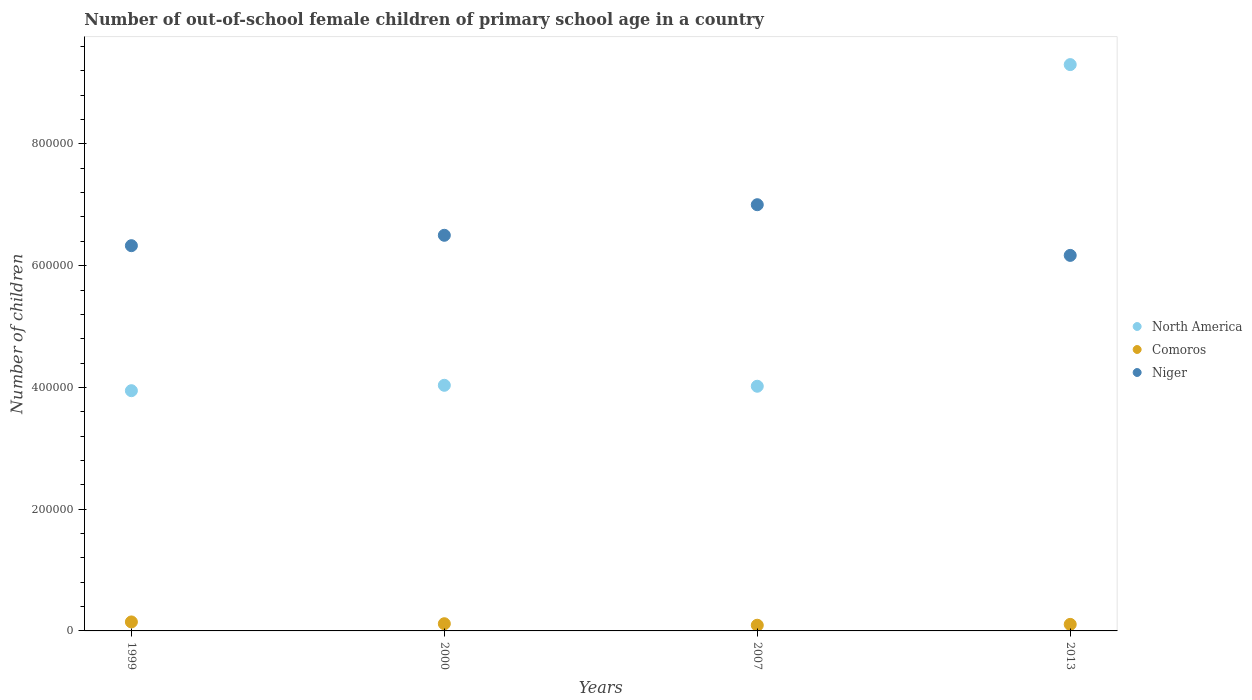Is the number of dotlines equal to the number of legend labels?
Offer a very short reply. Yes. What is the number of out-of-school female children in North America in 2007?
Make the answer very short. 4.02e+05. Across all years, what is the maximum number of out-of-school female children in Niger?
Provide a succinct answer. 7.00e+05. Across all years, what is the minimum number of out-of-school female children in Comoros?
Your answer should be very brief. 9336. In which year was the number of out-of-school female children in North America maximum?
Your answer should be compact. 2013. In which year was the number of out-of-school female children in Comoros minimum?
Give a very brief answer. 2007. What is the total number of out-of-school female children in Niger in the graph?
Your answer should be compact. 2.60e+06. What is the difference between the number of out-of-school female children in North America in 1999 and that in 2000?
Your response must be concise. -8858. What is the difference between the number of out-of-school female children in North America in 2000 and the number of out-of-school female children in Comoros in 2007?
Ensure brevity in your answer.  3.94e+05. What is the average number of out-of-school female children in North America per year?
Ensure brevity in your answer.  5.33e+05. In the year 2007, what is the difference between the number of out-of-school female children in Niger and number of out-of-school female children in Comoros?
Your response must be concise. 6.91e+05. What is the ratio of the number of out-of-school female children in Comoros in 1999 to that in 2013?
Give a very brief answer. 1.37. Is the difference between the number of out-of-school female children in Niger in 2000 and 2013 greater than the difference between the number of out-of-school female children in Comoros in 2000 and 2013?
Your answer should be compact. Yes. What is the difference between the highest and the second highest number of out-of-school female children in North America?
Offer a very short reply. 5.27e+05. What is the difference between the highest and the lowest number of out-of-school female children in Niger?
Ensure brevity in your answer.  8.32e+04. Is the sum of the number of out-of-school female children in Niger in 1999 and 2000 greater than the maximum number of out-of-school female children in North America across all years?
Offer a very short reply. Yes. Is the number of out-of-school female children in North America strictly greater than the number of out-of-school female children in Niger over the years?
Keep it short and to the point. No. How many dotlines are there?
Your response must be concise. 3. How many years are there in the graph?
Offer a very short reply. 4. Does the graph contain grids?
Offer a terse response. No. What is the title of the graph?
Give a very brief answer. Number of out-of-school female children of primary school age in a country. Does "Zambia" appear as one of the legend labels in the graph?
Provide a succinct answer. No. What is the label or title of the Y-axis?
Offer a very short reply. Number of children. What is the Number of children in North America in 1999?
Ensure brevity in your answer.  3.95e+05. What is the Number of children of Comoros in 1999?
Your response must be concise. 1.48e+04. What is the Number of children in Niger in 1999?
Give a very brief answer. 6.33e+05. What is the Number of children of North America in 2000?
Give a very brief answer. 4.03e+05. What is the Number of children in Comoros in 2000?
Provide a succinct answer. 1.18e+04. What is the Number of children in Niger in 2000?
Keep it short and to the point. 6.50e+05. What is the Number of children of North America in 2007?
Ensure brevity in your answer.  4.02e+05. What is the Number of children in Comoros in 2007?
Give a very brief answer. 9336. What is the Number of children in Niger in 2007?
Ensure brevity in your answer.  7.00e+05. What is the Number of children in North America in 2013?
Your answer should be very brief. 9.30e+05. What is the Number of children in Comoros in 2013?
Provide a succinct answer. 1.07e+04. What is the Number of children in Niger in 2013?
Your answer should be compact. 6.17e+05. Across all years, what is the maximum Number of children of North America?
Keep it short and to the point. 9.30e+05. Across all years, what is the maximum Number of children of Comoros?
Your response must be concise. 1.48e+04. Across all years, what is the maximum Number of children of Niger?
Ensure brevity in your answer.  7.00e+05. Across all years, what is the minimum Number of children of North America?
Offer a terse response. 3.95e+05. Across all years, what is the minimum Number of children of Comoros?
Your answer should be compact. 9336. Across all years, what is the minimum Number of children of Niger?
Make the answer very short. 6.17e+05. What is the total Number of children in North America in the graph?
Give a very brief answer. 2.13e+06. What is the total Number of children of Comoros in the graph?
Keep it short and to the point. 4.67e+04. What is the total Number of children of Niger in the graph?
Offer a very short reply. 2.60e+06. What is the difference between the Number of children in North America in 1999 and that in 2000?
Your response must be concise. -8858. What is the difference between the Number of children of Comoros in 1999 and that in 2000?
Provide a succinct answer. 2941. What is the difference between the Number of children of Niger in 1999 and that in 2000?
Keep it short and to the point. -1.71e+04. What is the difference between the Number of children of North America in 1999 and that in 2007?
Ensure brevity in your answer.  -7308. What is the difference between the Number of children in Comoros in 1999 and that in 2007?
Offer a very short reply. 5426. What is the difference between the Number of children of Niger in 1999 and that in 2007?
Your answer should be very brief. -6.73e+04. What is the difference between the Number of children of North America in 1999 and that in 2013?
Offer a very short reply. -5.36e+05. What is the difference between the Number of children in Comoros in 1999 and that in 2013?
Make the answer very short. 4013. What is the difference between the Number of children of Niger in 1999 and that in 2013?
Your answer should be compact. 1.59e+04. What is the difference between the Number of children in North America in 2000 and that in 2007?
Provide a short and direct response. 1550. What is the difference between the Number of children in Comoros in 2000 and that in 2007?
Provide a succinct answer. 2485. What is the difference between the Number of children in Niger in 2000 and that in 2007?
Your answer should be very brief. -5.02e+04. What is the difference between the Number of children of North America in 2000 and that in 2013?
Offer a very short reply. -5.27e+05. What is the difference between the Number of children of Comoros in 2000 and that in 2013?
Your response must be concise. 1072. What is the difference between the Number of children in Niger in 2000 and that in 2013?
Your response must be concise. 3.30e+04. What is the difference between the Number of children in North America in 2007 and that in 2013?
Your response must be concise. -5.28e+05. What is the difference between the Number of children of Comoros in 2007 and that in 2013?
Give a very brief answer. -1413. What is the difference between the Number of children of Niger in 2007 and that in 2013?
Offer a terse response. 8.32e+04. What is the difference between the Number of children in North America in 1999 and the Number of children in Comoros in 2000?
Ensure brevity in your answer.  3.83e+05. What is the difference between the Number of children of North America in 1999 and the Number of children of Niger in 2000?
Keep it short and to the point. -2.55e+05. What is the difference between the Number of children of Comoros in 1999 and the Number of children of Niger in 2000?
Your answer should be very brief. -6.35e+05. What is the difference between the Number of children of North America in 1999 and the Number of children of Comoros in 2007?
Ensure brevity in your answer.  3.85e+05. What is the difference between the Number of children in North America in 1999 and the Number of children in Niger in 2007?
Offer a very short reply. -3.06e+05. What is the difference between the Number of children of Comoros in 1999 and the Number of children of Niger in 2007?
Make the answer very short. -6.85e+05. What is the difference between the Number of children in North America in 1999 and the Number of children in Comoros in 2013?
Offer a terse response. 3.84e+05. What is the difference between the Number of children of North America in 1999 and the Number of children of Niger in 2013?
Your response must be concise. -2.22e+05. What is the difference between the Number of children of Comoros in 1999 and the Number of children of Niger in 2013?
Make the answer very short. -6.02e+05. What is the difference between the Number of children of North America in 2000 and the Number of children of Comoros in 2007?
Keep it short and to the point. 3.94e+05. What is the difference between the Number of children of North America in 2000 and the Number of children of Niger in 2007?
Ensure brevity in your answer.  -2.97e+05. What is the difference between the Number of children in Comoros in 2000 and the Number of children in Niger in 2007?
Offer a very short reply. -6.88e+05. What is the difference between the Number of children of North America in 2000 and the Number of children of Comoros in 2013?
Ensure brevity in your answer.  3.93e+05. What is the difference between the Number of children in North America in 2000 and the Number of children in Niger in 2013?
Your answer should be very brief. -2.13e+05. What is the difference between the Number of children in Comoros in 2000 and the Number of children in Niger in 2013?
Provide a short and direct response. -6.05e+05. What is the difference between the Number of children in North America in 2007 and the Number of children in Comoros in 2013?
Provide a short and direct response. 3.91e+05. What is the difference between the Number of children in North America in 2007 and the Number of children in Niger in 2013?
Make the answer very short. -2.15e+05. What is the difference between the Number of children in Comoros in 2007 and the Number of children in Niger in 2013?
Offer a very short reply. -6.08e+05. What is the average Number of children of North America per year?
Make the answer very short. 5.33e+05. What is the average Number of children in Comoros per year?
Provide a succinct answer. 1.17e+04. What is the average Number of children in Niger per year?
Provide a succinct answer. 6.50e+05. In the year 1999, what is the difference between the Number of children of North America and Number of children of Comoros?
Give a very brief answer. 3.80e+05. In the year 1999, what is the difference between the Number of children in North America and Number of children in Niger?
Offer a very short reply. -2.38e+05. In the year 1999, what is the difference between the Number of children of Comoros and Number of children of Niger?
Your answer should be compact. -6.18e+05. In the year 2000, what is the difference between the Number of children in North America and Number of children in Comoros?
Ensure brevity in your answer.  3.92e+05. In the year 2000, what is the difference between the Number of children of North America and Number of children of Niger?
Your answer should be compact. -2.46e+05. In the year 2000, what is the difference between the Number of children in Comoros and Number of children in Niger?
Keep it short and to the point. -6.38e+05. In the year 2007, what is the difference between the Number of children in North America and Number of children in Comoros?
Your answer should be very brief. 3.93e+05. In the year 2007, what is the difference between the Number of children of North America and Number of children of Niger?
Keep it short and to the point. -2.98e+05. In the year 2007, what is the difference between the Number of children of Comoros and Number of children of Niger?
Provide a succinct answer. -6.91e+05. In the year 2013, what is the difference between the Number of children of North America and Number of children of Comoros?
Provide a short and direct response. 9.20e+05. In the year 2013, what is the difference between the Number of children of North America and Number of children of Niger?
Give a very brief answer. 3.13e+05. In the year 2013, what is the difference between the Number of children of Comoros and Number of children of Niger?
Provide a succinct answer. -6.06e+05. What is the ratio of the Number of children of Comoros in 1999 to that in 2000?
Your answer should be compact. 1.25. What is the ratio of the Number of children of Niger in 1999 to that in 2000?
Your answer should be compact. 0.97. What is the ratio of the Number of children of North America in 1999 to that in 2007?
Offer a very short reply. 0.98. What is the ratio of the Number of children of Comoros in 1999 to that in 2007?
Give a very brief answer. 1.58. What is the ratio of the Number of children of Niger in 1999 to that in 2007?
Ensure brevity in your answer.  0.9. What is the ratio of the Number of children of North America in 1999 to that in 2013?
Offer a very short reply. 0.42. What is the ratio of the Number of children of Comoros in 1999 to that in 2013?
Offer a terse response. 1.37. What is the ratio of the Number of children in Niger in 1999 to that in 2013?
Offer a terse response. 1.03. What is the ratio of the Number of children in Comoros in 2000 to that in 2007?
Provide a succinct answer. 1.27. What is the ratio of the Number of children in Niger in 2000 to that in 2007?
Ensure brevity in your answer.  0.93. What is the ratio of the Number of children in North America in 2000 to that in 2013?
Your answer should be very brief. 0.43. What is the ratio of the Number of children in Comoros in 2000 to that in 2013?
Provide a succinct answer. 1.1. What is the ratio of the Number of children of Niger in 2000 to that in 2013?
Ensure brevity in your answer.  1.05. What is the ratio of the Number of children of North America in 2007 to that in 2013?
Provide a short and direct response. 0.43. What is the ratio of the Number of children of Comoros in 2007 to that in 2013?
Ensure brevity in your answer.  0.87. What is the ratio of the Number of children of Niger in 2007 to that in 2013?
Offer a terse response. 1.14. What is the difference between the highest and the second highest Number of children of North America?
Your response must be concise. 5.27e+05. What is the difference between the highest and the second highest Number of children in Comoros?
Your response must be concise. 2941. What is the difference between the highest and the second highest Number of children of Niger?
Your answer should be very brief. 5.02e+04. What is the difference between the highest and the lowest Number of children in North America?
Keep it short and to the point. 5.36e+05. What is the difference between the highest and the lowest Number of children in Comoros?
Offer a terse response. 5426. What is the difference between the highest and the lowest Number of children of Niger?
Your answer should be very brief. 8.32e+04. 